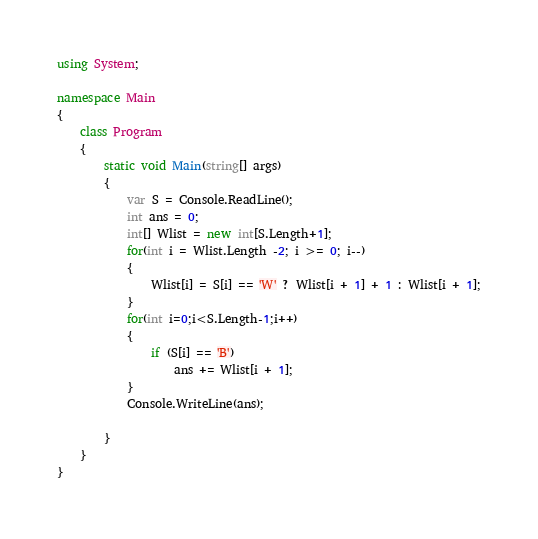<code> <loc_0><loc_0><loc_500><loc_500><_C#_>using System;

namespace Main
{
    class Program
    {
        static void Main(string[] args)
        {
            var S = Console.ReadLine();
            int ans = 0;
            int[] Wlist = new int[S.Length+1];
            for(int i = Wlist.Length -2; i >= 0; i--)
            {
                Wlist[i] = S[i] == 'W' ? Wlist[i + 1] + 1 : Wlist[i + 1];
            }
            for(int i=0;i<S.Length-1;i++)
            {
                if (S[i] == 'B')
                    ans += Wlist[i + 1];
            }
            Console.WriteLine(ans);

        }
    }
}
</code> 